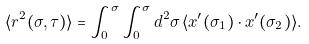<formula> <loc_0><loc_0><loc_500><loc_500>\langle r ^ { 2 } ( \sigma , \tau ) \rangle = \int _ { 0 } ^ { \sigma } \int _ { 0 } ^ { \sigma } d ^ { 2 } \sigma \, \langle x ^ { \prime } ( \sigma _ { 1 } ) \cdot x ^ { \prime } ( \sigma _ { 2 } ) \rangle .</formula> 